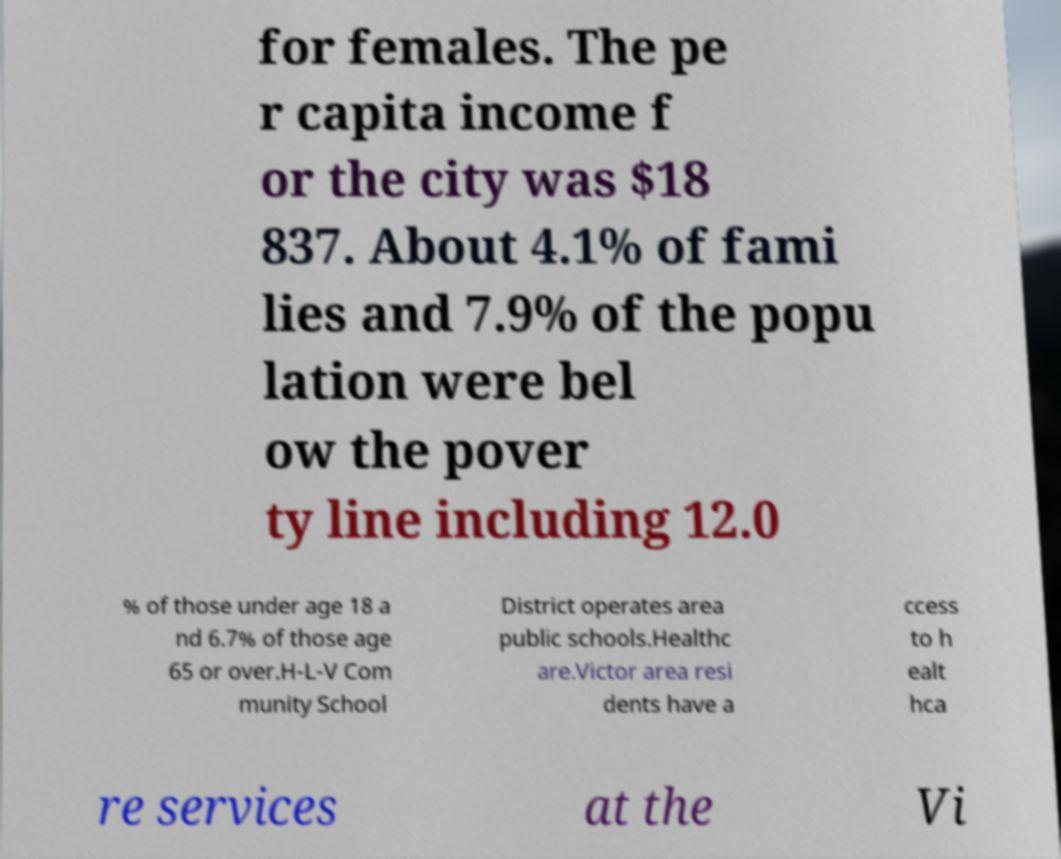There's text embedded in this image that I need extracted. Can you transcribe it verbatim? for females. The pe r capita income f or the city was $18 837. About 4.1% of fami lies and 7.9% of the popu lation were bel ow the pover ty line including 12.0 % of those under age 18 a nd 6.7% of those age 65 or over.H-L-V Com munity School District operates area public schools.Healthc are.Victor area resi dents have a ccess to h ealt hca re services at the Vi 